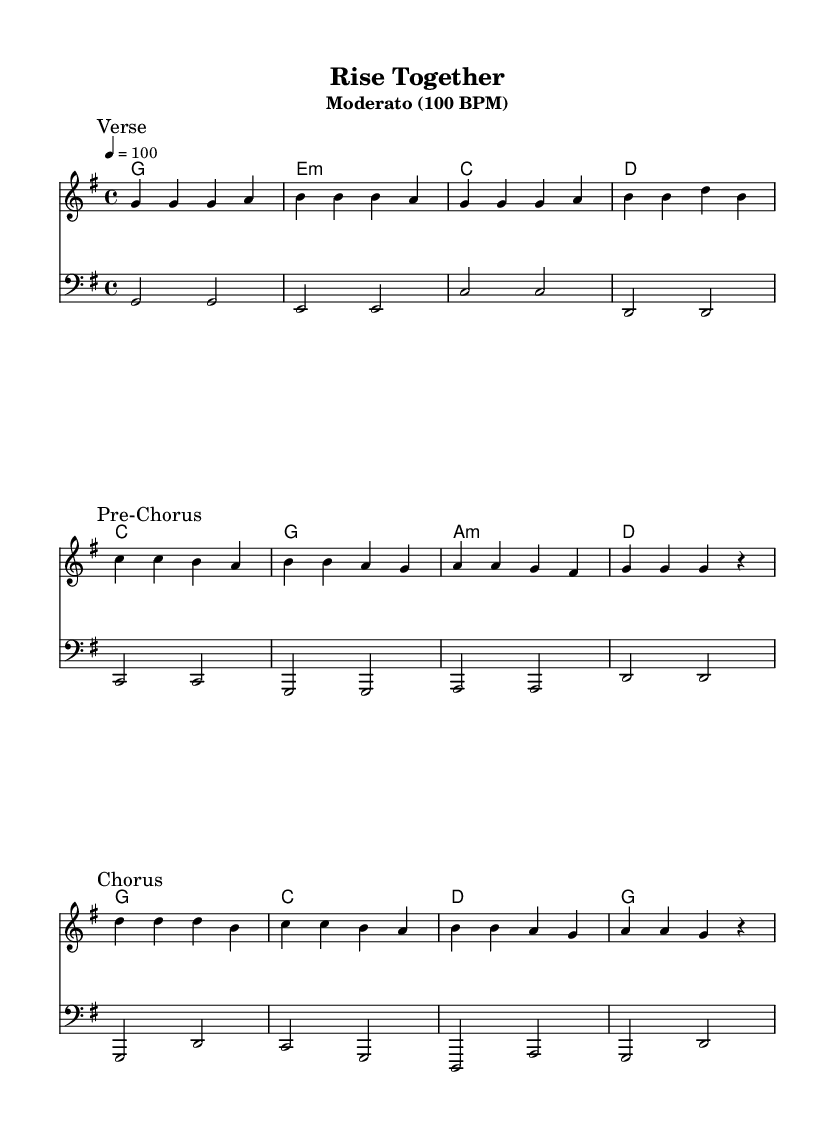What is the key signature of this music? The key signature is G major, which has one sharp (F sharp). This can be determined by looking at the key signature indicated at the beginning of the sheet music.
Answer: G major What is the time signature of this music? The time signature is 4/4, as seen in the time signature marking near the beginning of the music. It indicates that there are four beats in each measure.
Answer: 4/4 What is the tempo marking of this piece? The tempo marking is Moderato, which typically indicates a moderate speed around 100 beats per minute, as specified in the tempo indication at the top.
Answer: Moderato (100 BPM) How many sections are in the song structure? The song structure contains three main sections: Verse, Pre-Chorus, and Chorus, as indicated by the marks in the music.
Answer: Three In what part of the song do the lyrics mention "building dreams"? The lyrics mentioning "building dreams, brick by brick" are found in the Verse section, as indicated by the marked verse lyrics.
Answer: Verse What is the progression pattern of the harmonies in the Chorus? The harmonies in the Chorus follow the chords: D, C, B, A, which can be confirmed by looking at the chord progression lines during the Chorus section.
Answer: D C B A What is the primary theme conveyed in the lyrics? The primary theme in the lyrics focuses on community efforts and progress, emphasizing unity and togetherness, as expressed in the lines provided in the sheet music.
Answer: Community development 